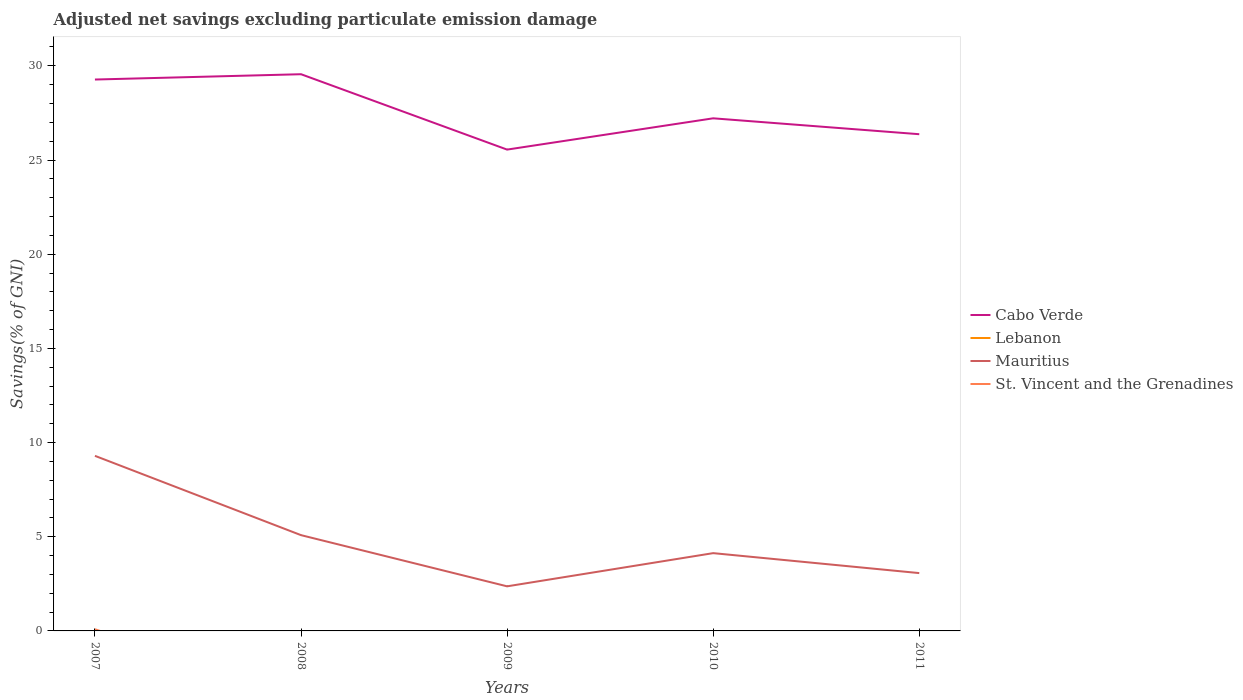How many different coloured lines are there?
Give a very brief answer. 3. Across all years, what is the maximum adjusted net savings in Cabo Verde?
Your answer should be compact. 25.55. What is the total adjusted net savings in Cabo Verde in the graph?
Your answer should be very brief. 3.19. What is the difference between the highest and the second highest adjusted net savings in St. Vincent and the Grenadines?
Your answer should be very brief. 0.09. Is the adjusted net savings in Mauritius strictly greater than the adjusted net savings in St. Vincent and the Grenadines over the years?
Give a very brief answer. No. What is the difference between two consecutive major ticks on the Y-axis?
Make the answer very short. 5. Does the graph contain any zero values?
Provide a succinct answer. Yes. Where does the legend appear in the graph?
Make the answer very short. Center right. How many legend labels are there?
Ensure brevity in your answer.  4. What is the title of the graph?
Your response must be concise. Adjusted net savings excluding particulate emission damage. Does "Guatemala" appear as one of the legend labels in the graph?
Keep it short and to the point. No. What is the label or title of the X-axis?
Your answer should be compact. Years. What is the label or title of the Y-axis?
Your response must be concise. Savings(% of GNI). What is the Savings(% of GNI) of Cabo Verde in 2007?
Offer a very short reply. 29.27. What is the Savings(% of GNI) in Lebanon in 2007?
Give a very brief answer. 0. What is the Savings(% of GNI) in Mauritius in 2007?
Your answer should be compact. 9.29. What is the Savings(% of GNI) in St. Vincent and the Grenadines in 2007?
Offer a terse response. 0.09. What is the Savings(% of GNI) in Cabo Verde in 2008?
Offer a terse response. 29.55. What is the Savings(% of GNI) of Lebanon in 2008?
Ensure brevity in your answer.  0. What is the Savings(% of GNI) in Mauritius in 2008?
Provide a succinct answer. 5.08. What is the Savings(% of GNI) of Cabo Verde in 2009?
Give a very brief answer. 25.55. What is the Savings(% of GNI) of Mauritius in 2009?
Offer a very short reply. 2.37. What is the Savings(% of GNI) in Cabo Verde in 2010?
Provide a succinct answer. 27.21. What is the Savings(% of GNI) of Mauritius in 2010?
Your answer should be very brief. 4.13. What is the Savings(% of GNI) in St. Vincent and the Grenadines in 2010?
Your answer should be very brief. 0. What is the Savings(% of GNI) of Cabo Verde in 2011?
Provide a short and direct response. 26.37. What is the Savings(% of GNI) of Mauritius in 2011?
Keep it short and to the point. 3.07. What is the Savings(% of GNI) in St. Vincent and the Grenadines in 2011?
Your answer should be very brief. 0. Across all years, what is the maximum Savings(% of GNI) in Cabo Verde?
Give a very brief answer. 29.55. Across all years, what is the maximum Savings(% of GNI) of Mauritius?
Provide a succinct answer. 9.29. Across all years, what is the maximum Savings(% of GNI) in St. Vincent and the Grenadines?
Ensure brevity in your answer.  0.09. Across all years, what is the minimum Savings(% of GNI) in Cabo Verde?
Make the answer very short. 25.55. Across all years, what is the minimum Savings(% of GNI) in Mauritius?
Keep it short and to the point. 2.37. What is the total Savings(% of GNI) in Cabo Verde in the graph?
Offer a very short reply. 137.96. What is the total Savings(% of GNI) of Mauritius in the graph?
Keep it short and to the point. 23.95. What is the total Savings(% of GNI) in St. Vincent and the Grenadines in the graph?
Make the answer very short. 0.09. What is the difference between the Savings(% of GNI) of Cabo Verde in 2007 and that in 2008?
Offer a terse response. -0.28. What is the difference between the Savings(% of GNI) of Mauritius in 2007 and that in 2008?
Ensure brevity in your answer.  4.21. What is the difference between the Savings(% of GNI) in Cabo Verde in 2007 and that in 2009?
Provide a short and direct response. 3.72. What is the difference between the Savings(% of GNI) of Mauritius in 2007 and that in 2009?
Your response must be concise. 6.93. What is the difference between the Savings(% of GNI) of Cabo Verde in 2007 and that in 2010?
Your response must be concise. 2.06. What is the difference between the Savings(% of GNI) of Mauritius in 2007 and that in 2010?
Your response must be concise. 5.17. What is the difference between the Savings(% of GNI) of Cabo Verde in 2007 and that in 2011?
Make the answer very short. 2.9. What is the difference between the Savings(% of GNI) in Mauritius in 2007 and that in 2011?
Ensure brevity in your answer.  6.23. What is the difference between the Savings(% of GNI) in Cabo Verde in 2008 and that in 2009?
Provide a succinct answer. 4. What is the difference between the Savings(% of GNI) in Mauritius in 2008 and that in 2009?
Keep it short and to the point. 2.72. What is the difference between the Savings(% of GNI) of Cabo Verde in 2008 and that in 2010?
Provide a succinct answer. 2.34. What is the difference between the Savings(% of GNI) in Mauritius in 2008 and that in 2010?
Provide a succinct answer. 0.96. What is the difference between the Savings(% of GNI) in Cabo Verde in 2008 and that in 2011?
Your answer should be compact. 3.19. What is the difference between the Savings(% of GNI) in Mauritius in 2008 and that in 2011?
Keep it short and to the point. 2.01. What is the difference between the Savings(% of GNI) of Cabo Verde in 2009 and that in 2010?
Keep it short and to the point. -1.66. What is the difference between the Savings(% of GNI) in Mauritius in 2009 and that in 2010?
Offer a terse response. -1.76. What is the difference between the Savings(% of GNI) of Cabo Verde in 2009 and that in 2011?
Your answer should be compact. -0.82. What is the difference between the Savings(% of GNI) in Mauritius in 2009 and that in 2011?
Ensure brevity in your answer.  -0.7. What is the difference between the Savings(% of GNI) in Cabo Verde in 2010 and that in 2011?
Offer a very short reply. 0.84. What is the difference between the Savings(% of GNI) in Mauritius in 2010 and that in 2011?
Provide a succinct answer. 1.06. What is the difference between the Savings(% of GNI) in Cabo Verde in 2007 and the Savings(% of GNI) in Mauritius in 2008?
Provide a succinct answer. 24.19. What is the difference between the Savings(% of GNI) of Cabo Verde in 2007 and the Savings(% of GNI) of Mauritius in 2009?
Make the answer very short. 26.9. What is the difference between the Savings(% of GNI) in Cabo Verde in 2007 and the Savings(% of GNI) in Mauritius in 2010?
Provide a short and direct response. 25.14. What is the difference between the Savings(% of GNI) of Cabo Verde in 2007 and the Savings(% of GNI) of Mauritius in 2011?
Provide a succinct answer. 26.2. What is the difference between the Savings(% of GNI) in Cabo Verde in 2008 and the Savings(% of GNI) in Mauritius in 2009?
Your answer should be compact. 27.19. What is the difference between the Savings(% of GNI) of Cabo Verde in 2008 and the Savings(% of GNI) of Mauritius in 2010?
Keep it short and to the point. 25.43. What is the difference between the Savings(% of GNI) in Cabo Verde in 2008 and the Savings(% of GNI) in Mauritius in 2011?
Ensure brevity in your answer.  26.48. What is the difference between the Savings(% of GNI) in Cabo Verde in 2009 and the Savings(% of GNI) in Mauritius in 2010?
Your answer should be very brief. 21.42. What is the difference between the Savings(% of GNI) in Cabo Verde in 2009 and the Savings(% of GNI) in Mauritius in 2011?
Your response must be concise. 22.48. What is the difference between the Savings(% of GNI) in Cabo Verde in 2010 and the Savings(% of GNI) in Mauritius in 2011?
Keep it short and to the point. 24.14. What is the average Savings(% of GNI) of Cabo Verde per year?
Provide a short and direct response. 27.59. What is the average Savings(% of GNI) in Lebanon per year?
Make the answer very short. 0. What is the average Savings(% of GNI) in Mauritius per year?
Make the answer very short. 4.79. What is the average Savings(% of GNI) in St. Vincent and the Grenadines per year?
Ensure brevity in your answer.  0.02. In the year 2007, what is the difference between the Savings(% of GNI) in Cabo Verde and Savings(% of GNI) in Mauritius?
Offer a very short reply. 19.98. In the year 2007, what is the difference between the Savings(% of GNI) of Cabo Verde and Savings(% of GNI) of St. Vincent and the Grenadines?
Make the answer very short. 29.18. In the year 2007, what is the difference between the Savings(% of GNI) in Mauritius and Savings(% of GNI) in St. Vincent and the Grenadines?
Give a very brief answer. 9.21. In the year 2008, what is the difference between the Savings(% of GNI) of Cabo Verde and Savings(% of GNI) of Mauritius?
Offer a very short reply. 24.47. In the year 2009, what is the difference between the Savings(% of GNI) in Cabo Verde and Savings(% of GNI) in Mauritius?
Your answer should be compact. 23.19. In the year 2010, what is the difference between the Savings(% of GNI) in Cabo Verde and Savings(% of GNI) in Mauritius?
Offer a terse response. 23.08. In the year 2011, what is the difference between the Savings(% of GNI) of Cabo Verde and Savings(% of GNI) of Mauritius?
Keep it short and to the point. 23.3. What is the ratio of the Savings(% of GNI) of Cabo Verde in 2007 to that in 2008?
Ensure brevity in your answer.  0.99. What is the ratio of the Savings(% of GNI) of Mauritius in 2007 to that in 2008?
Make the answer very short. 1.83. What is the ratio of the Savings(% of GNI) in Cabo Verde in 2007 to that in 2009?
Your response must be concise. 1.15. What is the ratio of the Savings(% of GNI) in Mauritius in 2007 to that in 2009?
Provide a short and direct response. 3.93. What is the ratio of the Savings(% of GNI) of Cabo Verde in 2007 to that in 2010?
Make the answer very short. 1.08. What is the ratio of the Savings(% of GNI) of Mauritius in 2007 to that in 2010?
Your answer should be very brief. 2.25. What is the ratio of the Savings(% of GNI) in Cabo Verde in 2007 to that in 2011?
Your answer should be very brief. 1.11. What is the ratio of the Savings(% of GNI) of Mauritius in 2007 to that in 2011?
Give a very brief answer. 3.03. What is the ratio of the Savings(% of GNI) in Cabo Verde in 2008 to that in 2009?
Keep it short and to the point. 1.16. What is the ratio of the Savings(% of GNI) of Mauritius in 2008 to that in 2009?
Make the answer very short. 2.15. What is the ratio of the Savings(% of GNI) of Cabo Verde in 2008 to that in 2010?
Offer a very short reply. 1.09. What is the ratio of the Savings(% of GNI) in Mauritius in 2008 to that in 2010?
Ensure brevity in your answer.  1.23. What is the ratio of the Savings(% of GNI) in Cabo Verde in 2008 to that in 2011?
Provide a short and direct response. 1.12. What is the ratio of the Savings(% of GNI) in Mauritius in 2008 to that in 2011?
Offer a terse response. 1.66. What is the ratio of the Savings(% of GNI) in Cabo Verde in 2009 to that in 2010?
Give a very brief answer. 0.94. What is the ratio of the Savings(% of GNI) in Mauritius in 2009 to that in 2010?
Your answer should be compact. 0.57. What is the ratio of the Savings(% of GNI) of Cabo Verde in 2009 to that in 2011?
Offer a very short reply. 0.97. What is the ratio of the Savings(% of GNI) in Mauritius in 2009 to that in 2011?
Provide a succinct answer. 0.77. What is the ratio of the Savings(% of GNI) of Cabo Verde in 2010 to that in 2011?
Your answer should be compact. 1.03. What is the ratio of the Savings(% of GNI) in Mauritius in 2010 to that in 2011?
Offer a very short reply. 1.35. What is the difference between the highest and the second highest Savings(% of GNI) of Cabo Verde?
Offer a very short reply. 0.28. What is the difference between the highest and the second highest Savings(% of GNI) in Mauritius?
Your response must be concise. 4.21. What is the difference between the highest and the lowest Savings(% of GNI) of Cabo Verde?
Make the answer very short. 4. What is the difference between the highest and the lowest Savings(% of GNI) of Mauritius?
Provide a succinct answer. 6.93. What is the difference between the highest and the lowest Savings(% of GNI) in St. Vincent and the Grenadines?
Your answer should be compact. 0.09. 